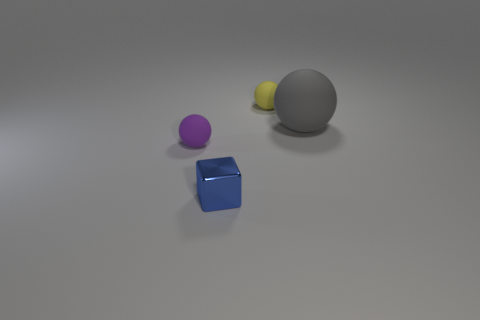Is there a blue metal thing that has the same shape as the big gray rubber thing?
Your response must be concise. No. What shape is the purple matte object that is the same size as the blue thing?
Your answer should be compact. Sphere. There is a small cube; is its color the same as the sphere on the left side of the tiny blue thing?
Your answer should be compact. No. There is a small matte ball that is on the left side of the tiny yellow matte thing; what number of things are left of it?
Your answer should be compact. 0. There is a rubber ball that is both in front of the yellow ball and to the right of the metallic block; how big is it?
Keep it short and to the point. Large. Are there any yellow rubber cubes that have the same size as the purple rubber thing?
Your answer should be compact. No. Is the number of blue shiny objects to the left of the metal object greater than the number of metal blocks that are on the right side of the yellow rubber object?
Offer a very short reply. No. Do the gray ball and the tiny object that is behind the big gray rubber sphere have the same material?
Make the answer very short. Yes. How many small yellow matte balls are to the right of the yellow matte thing that is behind the tiny matte object left of the small yellow object?
Offer a terse response. 0. There is a purple rubber thing; does it have the same shape as the small matte object to the right of the blue thing?
Your response must be concise. Yes. 